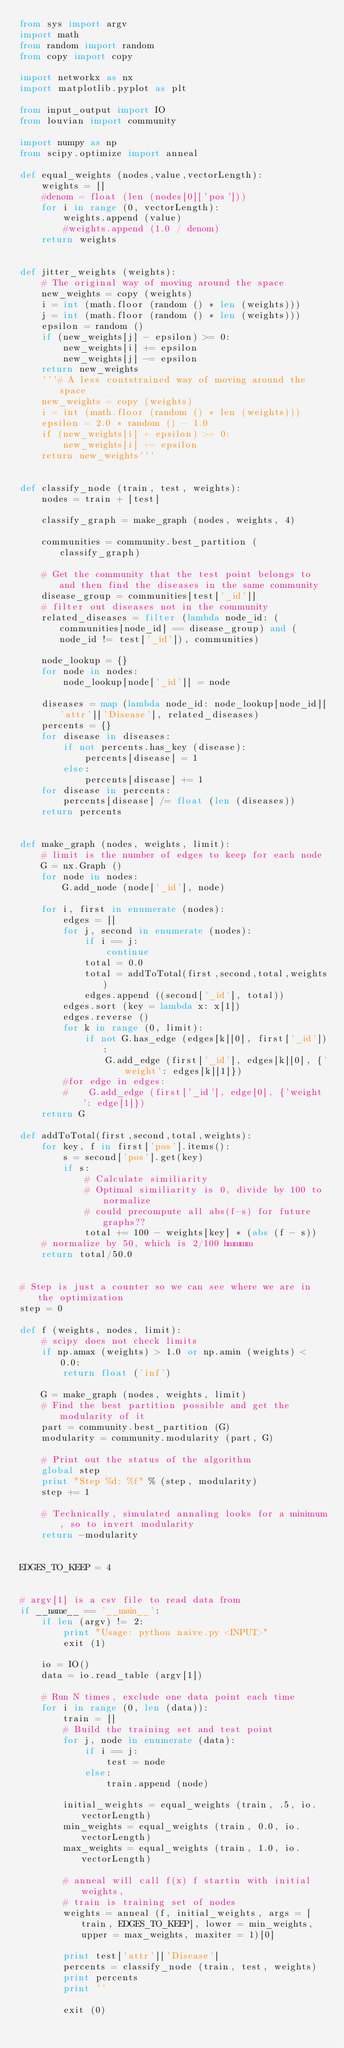<code> <loc_0><loc_0><loc_500><loc_500><_Python_>from sys import argv
import math
from random import random
from copy import copy

import networkx as nx
import matplotlib.pyplot as plt

from input_output import IO
from louvian import community

import numpy as np
from scipy.optimize import anneal

def equal_weights (nodes,value,vectorLength):
    weights = []
    #denom = float (len (nodes[0]['pos']))
    for i in range (0, vectorLength):
        weights.append (value)
        #weights.append (1.0 / denom)
    return weights


def jitter_weights (weights):
    # The original way of moving around the space
    new_weights = copy (weights)
    i = int (math.floor (random () * len (weights)))
    j = int (math.floor (random () * len (weights)))
    epsilon = random ()
    if (new_weights[j] - epsilon) >= 0:
        new_weights[i] += epsilon
        new_weights[j] -= epsilon
    return new_weights
    '''# A less contstrained way of moving around the space
    new_weights = copy (weights)
    i = int (math.floor (random () * len (weights)))
    epsilon = 2.0 * random () - 1.0
    if (new_weights[i] + epsilon) >= 0:
        new_weights[i] += epsilon
    return new_weights'''


def classify_node (train, test, weights): 
    nodes = train + [test]

    classify_graph = make_graph (nodes, weights, 4)

    communities = community.best_partition (classify_graph)

    # Get the community that the test point belongs to and then find the diseases in the same community
    disease_group = communities[test['_id']]
    # filter out diseases not in the community
    related_diseases = filter (lambda node_id: (communities[node_id] == disease_group) and (node_id != test['_id']), communities)

    node_lookup = {}
    for node in nodes:
        node_lookup[node['_id']] = node

    diseases = map (lambda node_id: node_lookup[node_id]['attr']['Disease'], related_diseases)
    percents = {}
    for disease in diseases:
        if not percents.has_key (disease):
            percents[disease] = 1
        else:
            percents[disease] += 1
    for disease in percents:
        percents[disease] /= float (len (diseases))
    return percents


def make_graph (nodes, weights, limit):
    # limit is the number of edges to keep for each node
    G = nx.Graph ()
    for node in nodes:
        G.add_node (node['_id'], node)

    for i, first in enumerate (nodes):
        edges = []
        for j, second in enumerate (nodes):
            if i == j:
                continue
            total = 0.0
            total = addToTotal(first,second,total,weights)
            edges.append ((second['_id'], total))
        edges.sort (key = lambda x: x[1])
        edges.reverse ()
        for k in range (0, limit):
            if not G.has_edge (edges[k][0], first['_id']):
                G.add_edge (first['_id'], edges[k][0], {'weight': edges[k][1]})
        #for edge in edges:
        #    G.add_edge (first['_id'], edge[0], {'weight': edge[1]})
    return G

def addToTotal(first,second,total,weights):
    for key, f in first['pos'].items():
        s = second['pos'].get(key)
        if s:
            # Calculate similiarity
            # Optimal similiarity is 0, divide by 100 to normalize
            # could precompute all abs(f-s) for future graphs??
            total += 100 - weights[key] * (abs (f - s))
    # normalize by 50, which is 2/100 hmmmm
    return total/50.0


# Step is just a counter so we can see where we are in the optimization
step = 0

def f (weights, nodes, limit):
    # scipy does not check limits
    if np.amax (weights) > 1.0 or np.amin (weights) < 0.0:
        return float ('inf')

    G = make_graph (nodes, weights, limit)
    # Find the best partition possible and get the modularity of it
    part = community.best_partition (G)
    modularity = community.modularity (part, G)

    # Print out the status of the algorithm
    global step
    print "Step %d: %f" % (step, modularity)
    step += 1

    # Technically, simulated annaling looks for a minimum, so to invert modularity
    return -modularity


EDGES_TO_KEEP = 4


# argv[1] is a csv file to read data from
if __name__ == '__main__':
    if len (argv) != 2:
        print "Usage: python naive.py <INPUT>"
        exit (1)

    io = IO()
    data = io.read_table (argv[1])

    # Run N times, exclude one data point each time
    for i in range (0, len (data)):
        train = []
        # Build the training set and test point
        for j, node in enumerate (data):
            if i == j:
                test = node
            else:
                train.append (node)

        initial_weights = equal_weights (train, .5, io.vectorLength)
        min_weights = equal_weights (train, 0.0, io.vectorLength)
        max_weights = equal_weights (train, 1.0, io.vectorLength)
        
        # anneal will call f(x) f startin with initial weights,
        # train is training set of nodes
        weights = anneal (f, initial_weights, args = [train, EDGES_TO_KEEP], lower = min_weights, upper = max_weights, maxiter = 1)[0]

        print test['attr']['Disease']
        percents = classify_node (train, test, weights)
        print percents
        print ''

        exit (0)
</code> 